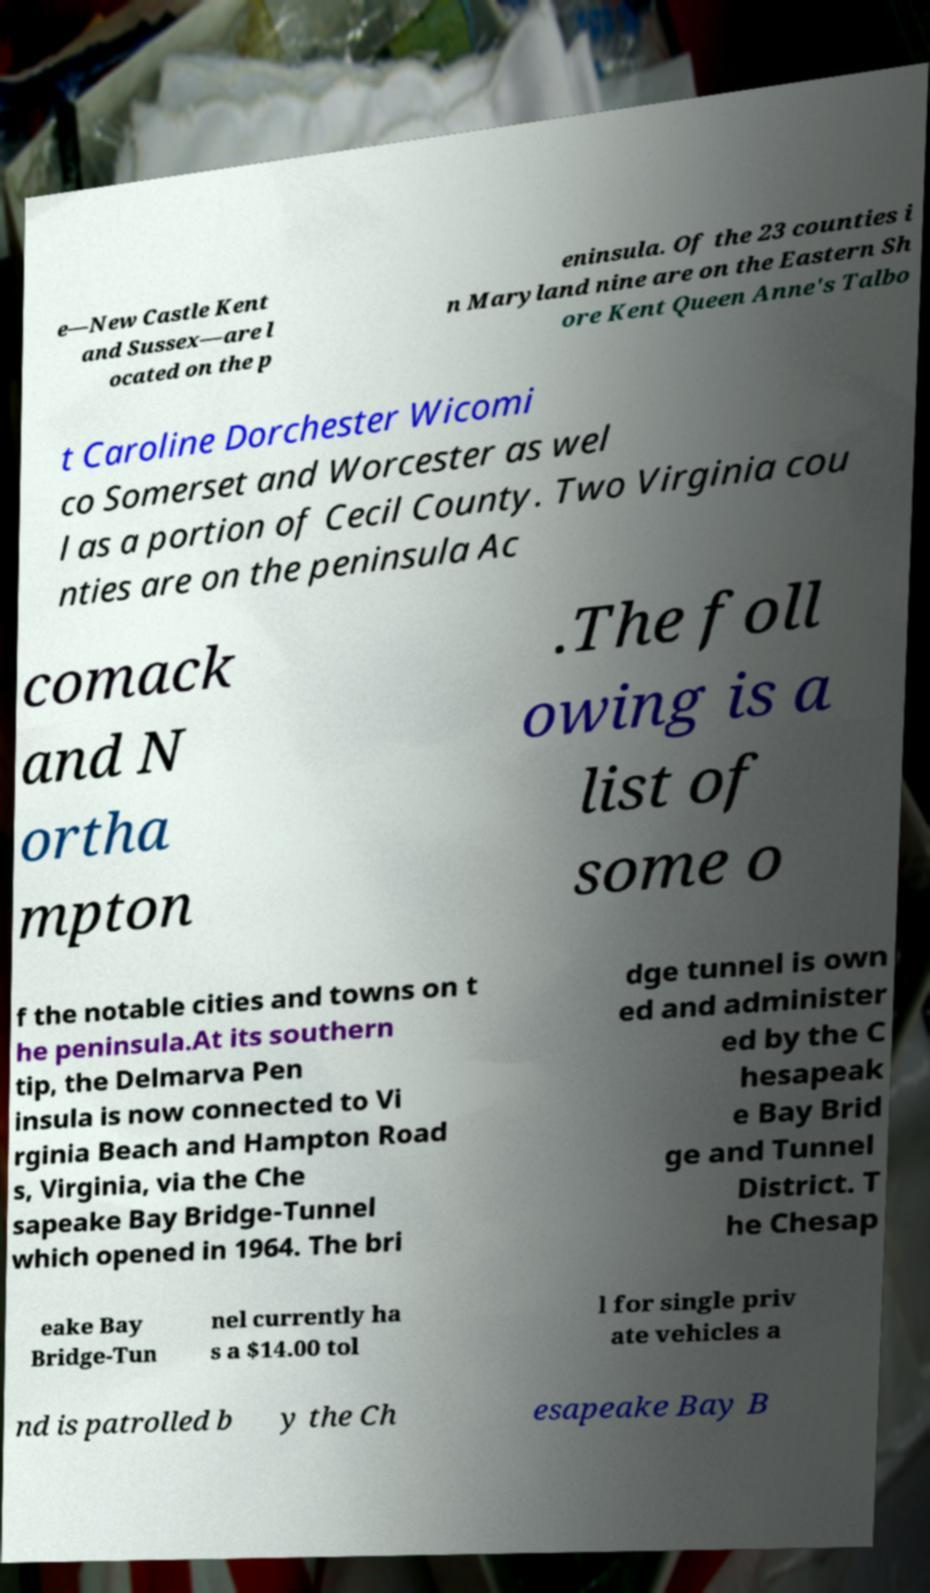Could you assist in decoding the text presented in this image and type it out clearly? e—New Castle Kent and Sussex—are l ocated on the p eninsula. Of the 23 counties i n Maryland nine are on the Eastern Sh ore Kent Queen Anne's Talbo t Caroline Dorchester Wicomi co Somerset and Worcester as wel l as a portion of Cecil County. Two Virginia cou nties are on the peninsula Ac comack and N ortha mpton .The foll owing is a list of some o f the notable cities and towns on t he peninsula.At its southern tip, the Delmarva Pen insula is now connected to Vi rginia Beach and Hampton Road s, Virginia, via the Che sapeake Bay Bridge-Tunnel which opened in 1964. The bri dge tunnel is own ed and administer ed by the C hesapeak e Bay Brid ge and Tunnel District. T he Chesap eake Bay Bridge-Tun nel currently ha s a $14.00 tol l for single priv ate vehicles a nd is patrolled b y the Ch esapeake Bay B 